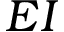<formula> <loc_0><loc_0><loc_500><loc_500>E I</formula> 